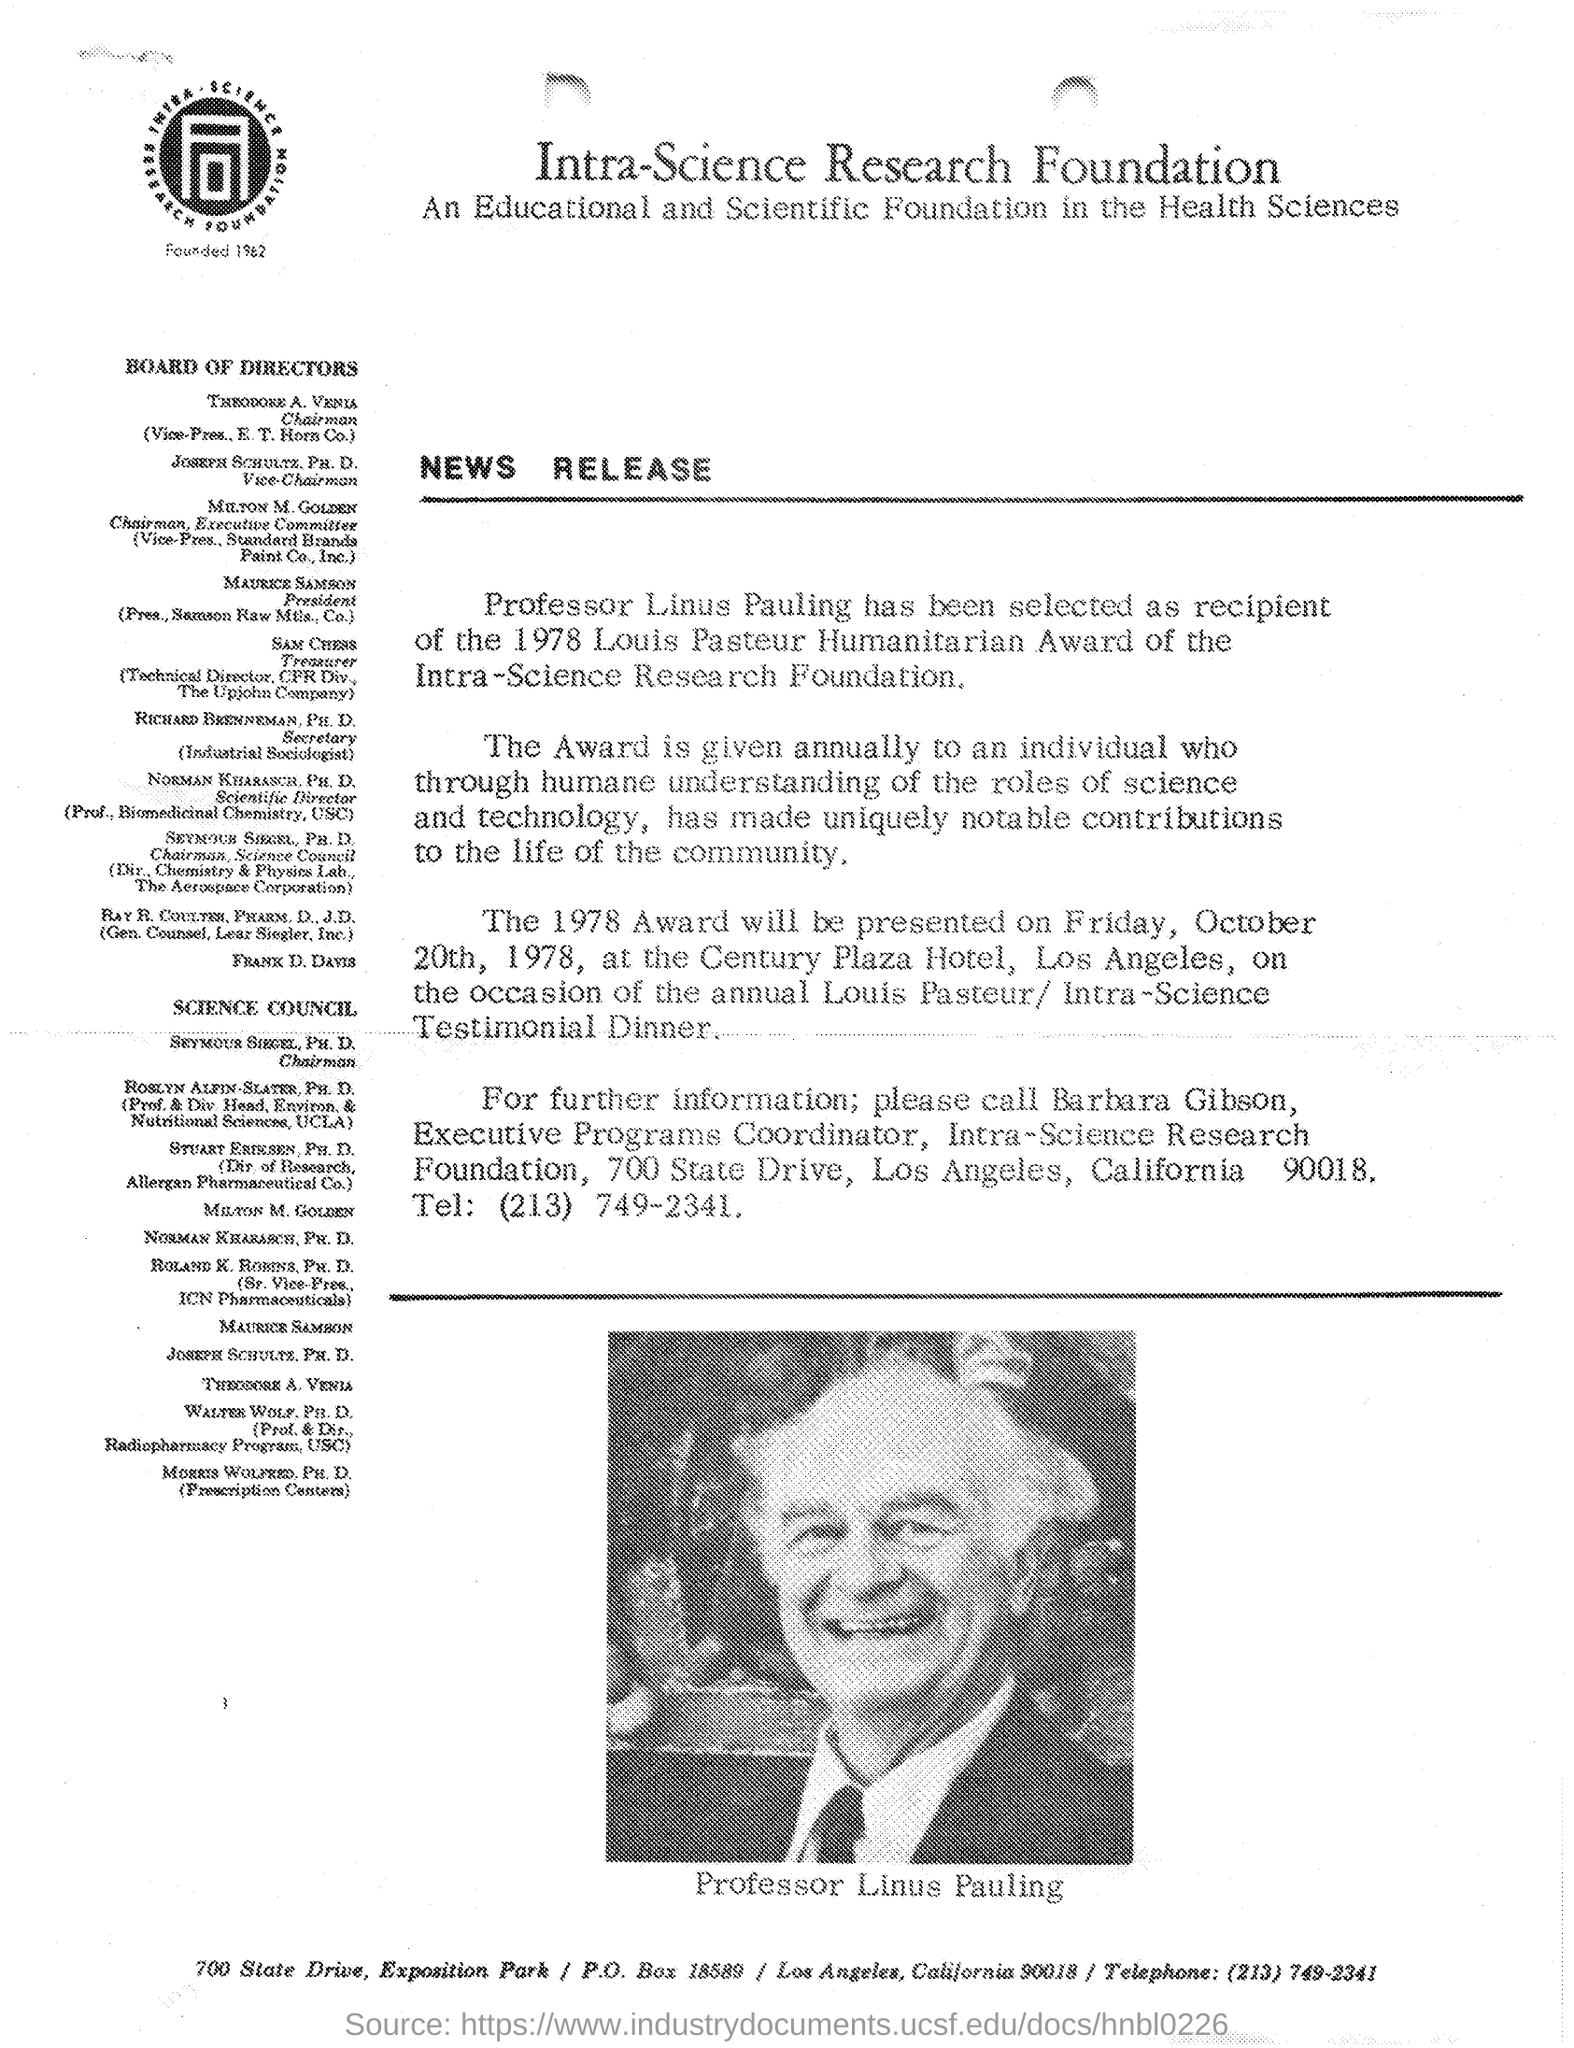What is name of person in image?
Provide a short and direct response. PROFESSOR LINUS PAULING. 